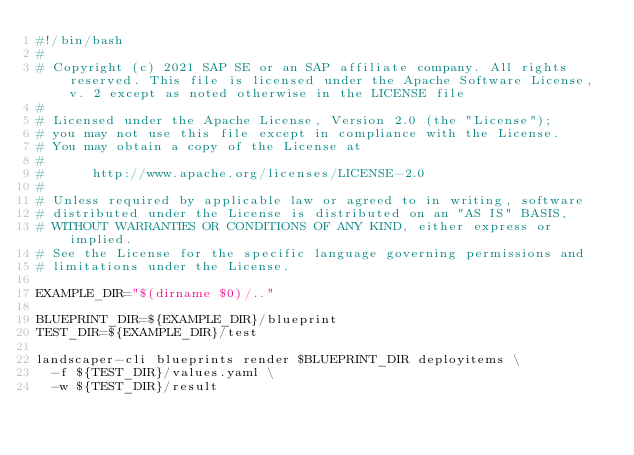Convert code to text. <code><loc_0><loc_0><loc_500><loc_500><_Bash_>#!/bin/bash
#
# Copyright (c) 2021 SAP SE or an SAP affiliate company. All rights reserved. This file is licensed under the Apache Software License, v. 2 except as noted otherwise in the LICENSE file
#
# Licensed under the Apache License, Version 2.0 (the "License");
# you may not use this file except in compliance with the License.
# You may obtain a copy of the License at
#
#      http://www.apache.org/licenses/LICENSE-2.0
#
# Unless required by applicable law or agreed to in writing, software
# distributed under the License is distributed on an "AS IS" BASIS,
# WITHOUT WARRANTIES OR CONDITIONS OF ANY KIND, either express or implied.
# See the License for the specific language governing permissions and
# limitations under the License.

EXAMPLE_DIR="$(dirname $0)/.."

BLUEPRINT_DIR=${EXAMPLE_DIR}/blueprint
TEST_DIR=${EXAMPLE_DIR}/test

landscaper-cli blueprints render $BLUEPRINT_DIR deployitems \
  -f ${TEST_DIR}/values.yaml \
  -w ${TEST_DIR}/result
</code> 